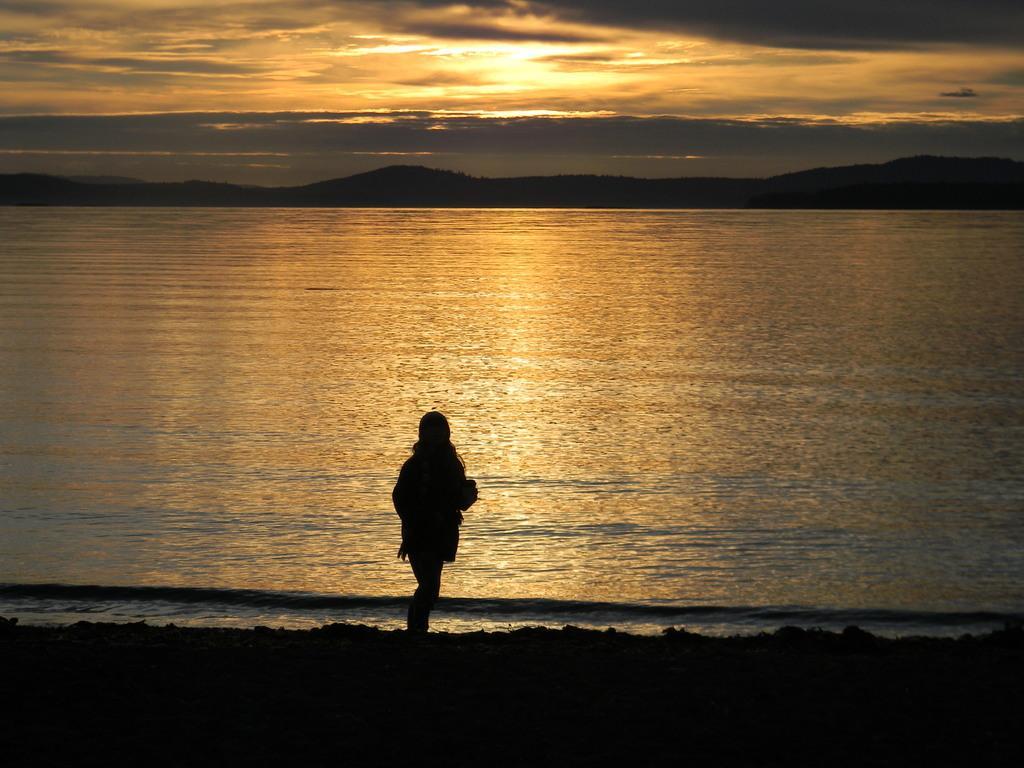Can you describe this image briefly? In this picture we can see a person is standing, and behind the person it looks like a lake. Behind the lake there are hills and the cloudy sky. 